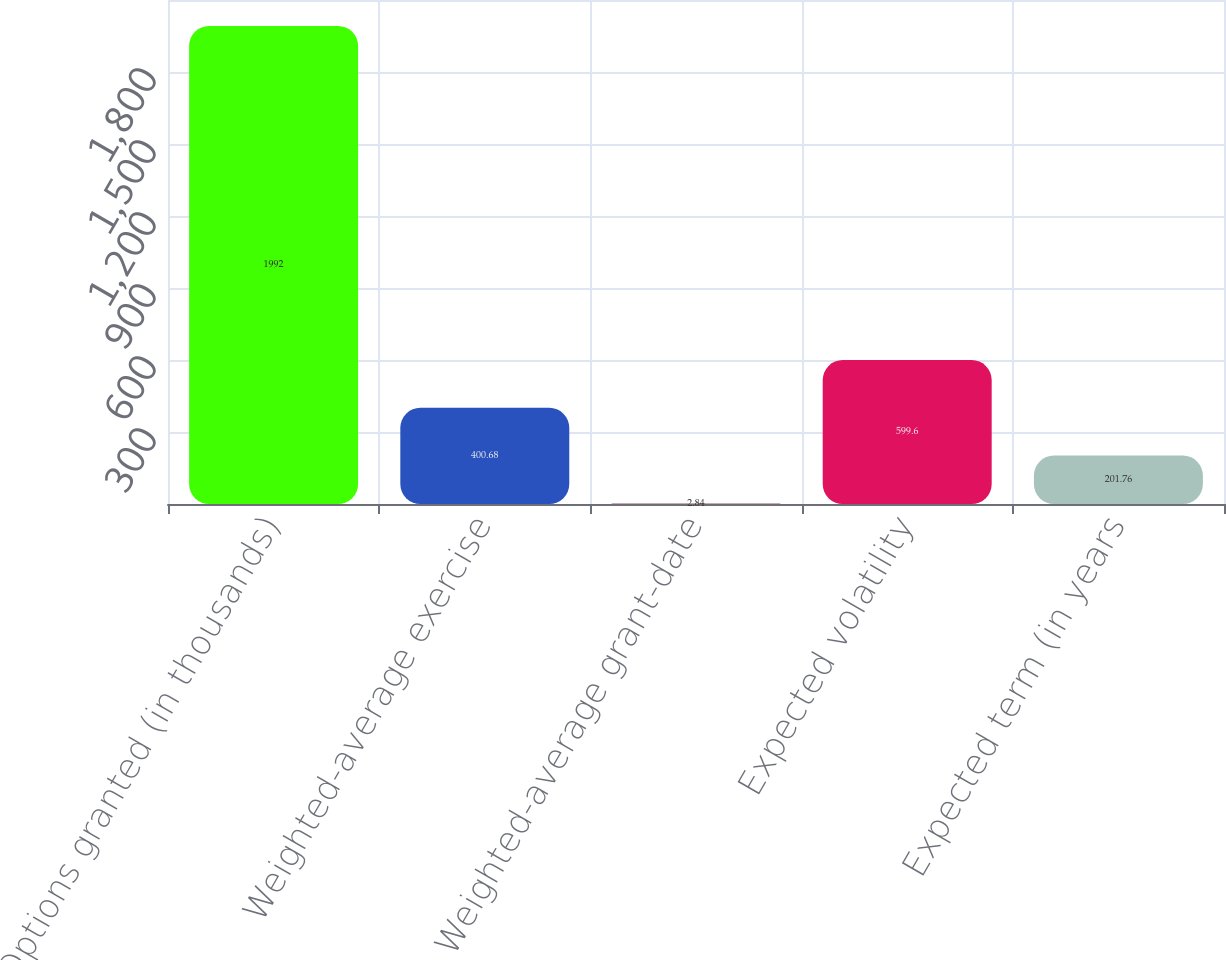Convert chart. <chart><loc_0><loc_0><loc_500><loc_500><bar_chart><fcel>Options granted (in thousands)<fcel>Weighted-average exercise<fcel>Weighted-average grant-date<fcel>Expected volatility<fcel>Expected term (in years<nl><fcel>1992<fcel>400.68<fcel>2.84<fcel>599.6<fcel>201.76<nl></chart> 